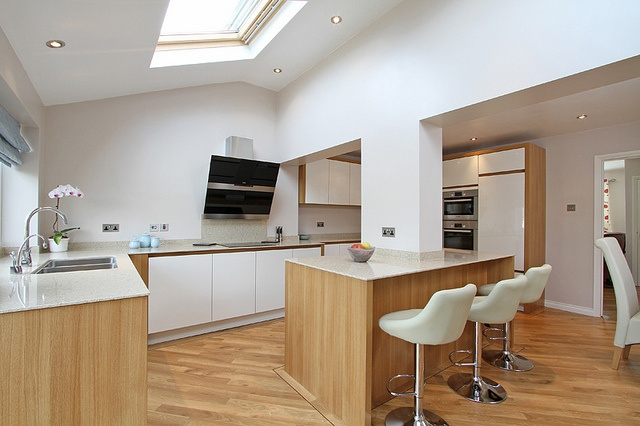Describe the objects in this image and their specific colors. I can see chair in darkgray, gray, lightgray, and maroon tones, chair in darkgray, gray, maroon, and black tones, tv in darkgray, black, and gray tones, chair in darkgray, gray, and lightgray tones, and microwave in darkgray, black, and gray tones in this image. 